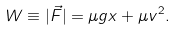Convert formula to latex. <formula><loc_0><loc_0><loc_500><loc_500>W \equiv | \vec { F } | = \mu g x + \mu v ^ { 2 } .</formula> 